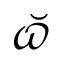<formula> <loc_0><loc_0><loc_500><loc_500>\breve { \varpi }</formula> 